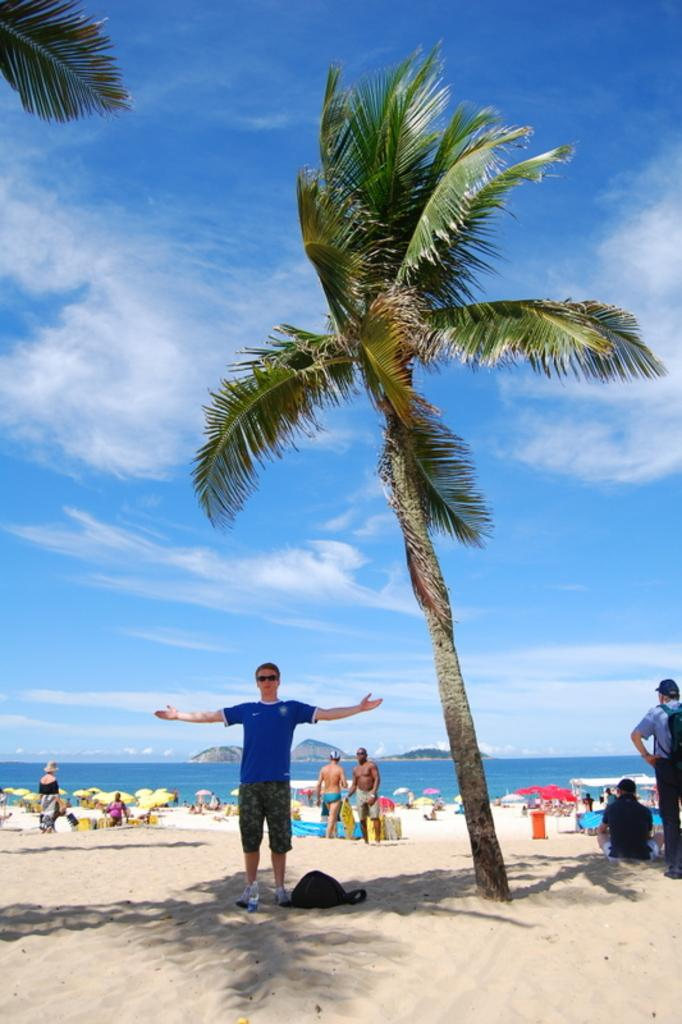What type of natural elements can be seen in the image? There are trees and mountains visible in the image. What are the people in the image doing? Some people are standing, while others are sitting on the ground. What is visible in the background of the image? There is sky, water, and mountains visible in the background of the image. What type of stone is being used to tie the people together in the image? There is no stone or any indication of people being tied together in the image. What color is the cord that is holding up the trees in the image? There is no cord or any indication of the trees being held up in the image. 